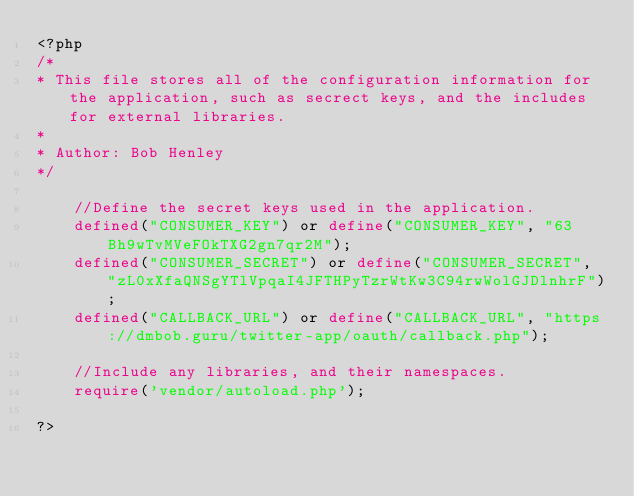Convert code to text. <code><loc_0><loc_0><loc_500><loc_500><_PHP_><?php
/*
* This file stores all of the configuration information for the application, such as secrect keys, and the includes for external libraries.
*
* Author: Bob Henley
*/
	
	//Define the secret keys used in the application.
	defined("CONSUMER_KEY") or define("CONSUMER_KEY", "63Bh9wTvMVeFOkTXG2gn7qr2M");
	defined("CONSUMER_SECRET") or define("CONSUMER_SECRET", "zL0xXfaQNSgYTlVpqaI4JFTHPyTzrWtKw3C94rwWolGJDlnhrF");
	defined("CALLBACK_URL") or define("CALLBACK_URL", "https://dmbob.guru/twitter-app/oauth/callback.php");

	//Include any libraries, and their namespaces.
	require('vendor/autoload.php');

?></code> 